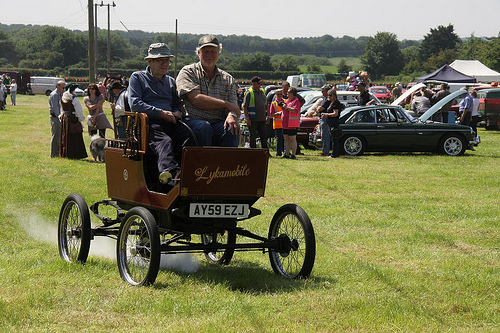<image>
Is there a car behind the woman? Yes. From this viewpoint, the car is positioned behind the woman, with the woman partially or fully occluding the car. Is the hat behind the man? Yes. From this viewpoint, the hat is positioned behind the man, with the man partially or fully occluding the hat. 